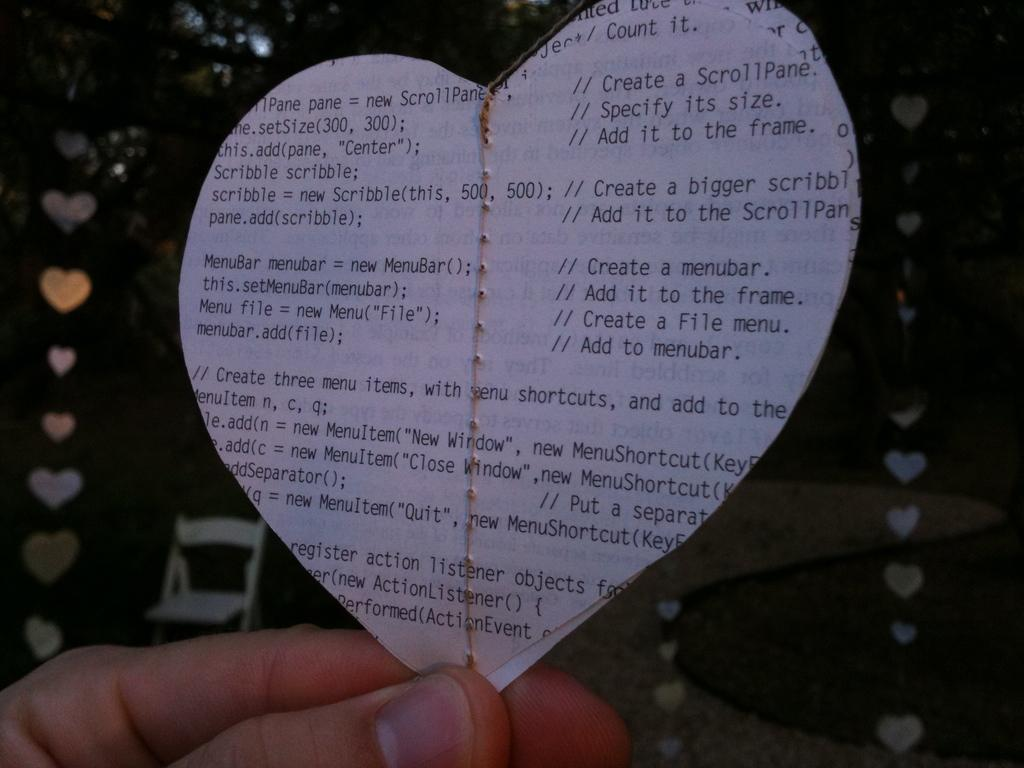What is the person's hand holding in the image? The person's hand is holding a paper in the shape of a heart at the bottom of the image. What shape is the paper in the image? The paper is shaped like a heart. What can be seen in the background of the image? There is a chair and decorative items in the background of the image. Can you see the father standing next to the stove in the image? There is no father or stove present in the image. What type of creature is on the moon in the image? There is no moon or creature present in the image. 